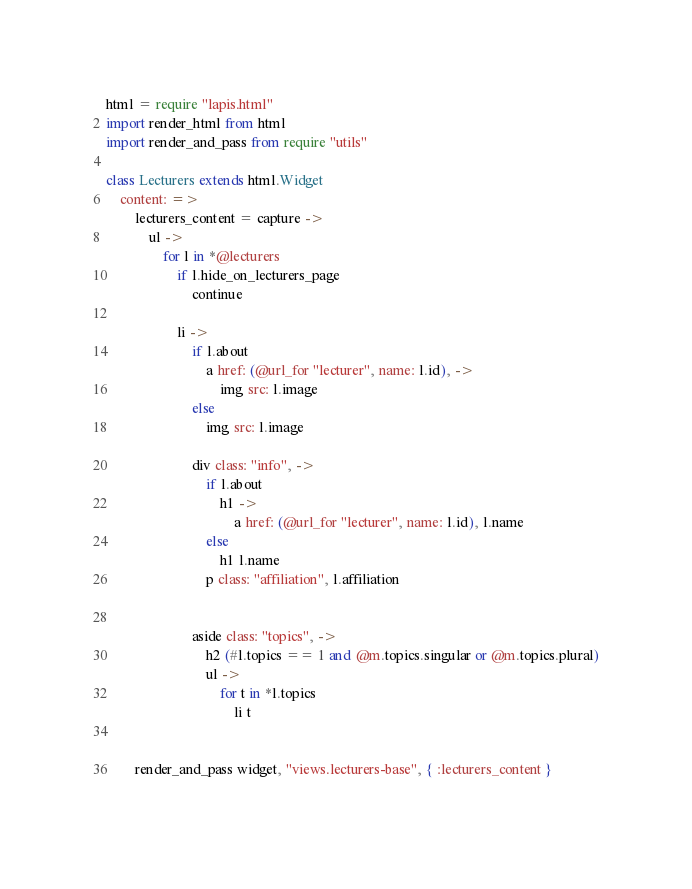<code> <loc_0><loc_0><loc_500><loc_500><_MoonScript_>html = require "lapis.html"
import render_html from html
import render_and_pass from require "utils"

class Lecturers extends html.Widget
    content: =>
        lecturers_content = capture ->
            ul ->
                for l in *@lecturers
                    if l.hide_on_lecturers_page
                        continue
                        
                    li ->
                        if l.about
                            a href: (@url_for "lecturer", name: l.id), ->
                                img src: l.image
                        else
                            img src: l.image

                        div class: "info", ->
                            if l.about
                                h1 ->
                                    a href: (@url_for "lecturer", name: l.id), l.name
                            else
                                h1 l.name
                            p class: "affiliation", l.affiliation


                        aside class: "topics", ->
                            h2 (#l.topics == 1 and @m.topics.singular or @m.topics.plural)
                            ul ->
                                for t in *l.topics 
                                    li t


        render_and_pass widget, "views.lecturers-base", { :lecturers_content }
       
</code> 